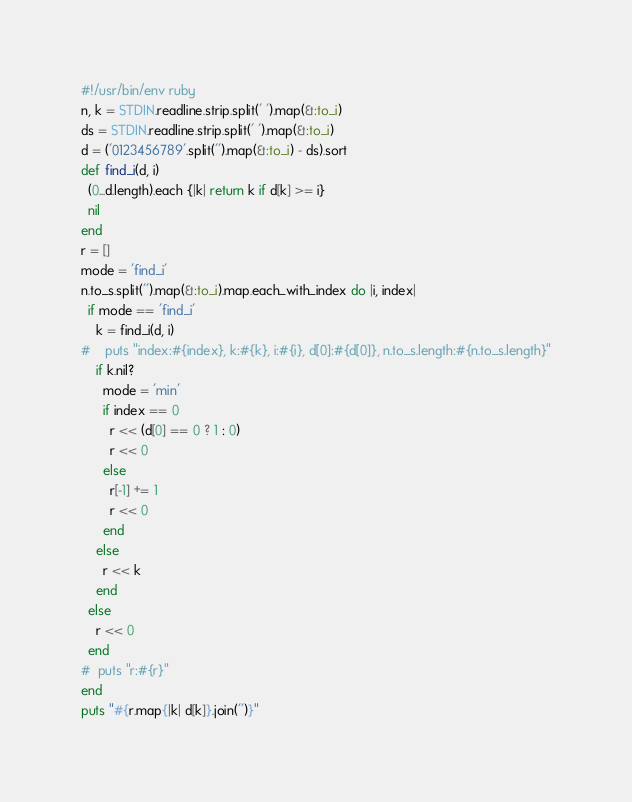<code> <loc_0><loc_0><loc_500><loc_500><_Ruby_>#!/usr/bin/env ruby
n, k = STDIN.readline.strip.split(' ').map(&:to_i)
ds = STDIN.readline.strip.split(' ').map(&:to_i)
d = ('0123456789'.split('').map(&:to_i) - ds).sort
def find_i(d, i)
  (0...d.length).each {|k| return k if d[k] >= i}
  nil
end
r = []
mode = 'find_i'
n.to_s.split('').map(&:to_i).map.each_with_index do |i, index|
  if mode == 'find_i'
    k = find_i(d, i)
#    puts "index:#{index}, k:#{k}, i:#{i}, d[0]:#{d[0]}, n.to_s.length:#{n.to_s.length}"
    if k.nil?
      mode = 'min'
      if index == 0
        r << (d[0] == 0 ? 1 : 0)
        r << 0
      else
        r[-1] += 1
        r << 0
      end
    else
      r << k
    end
  else
    r << 0
  end
#  puts "r:#{r}"
end
puts "#{r.map{|k| d[k]}.join('')}"
</code> 